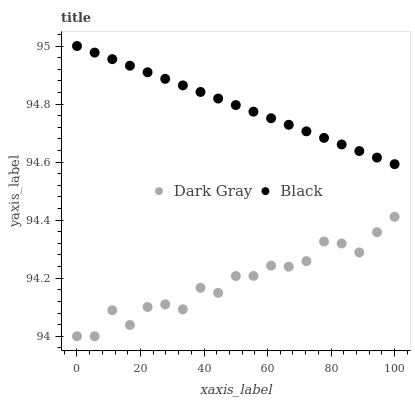Does Dark Gray have the minimum area under the curve?
Answer yes or no. Yes. Does Black have the maximum area under the curve?
Answer yes or no. Yes. Does Black have the minimum area under the curve?
Answer yes or no. No. Is Black the smoothest?
Answer yes or no. Yes. Is Dark Gray the roughest?
Answer yes or no. Yes. Is Black the roughest?
Answer yes or no. No. Does Dark Gray have the lowest value?
Answer yes or no. Yes. Does Black have the lowest value?
Answer yes or no. No. Does Black have the highest value?
Answer yes or no. Yes. Is Dark Gray less than Black?
Answer yes or no. Yes. Is Black greater than Dark Gray?
Answer yes or no. Yes. Does Dark Gray intersect Black?
Answer yes or no. No. 